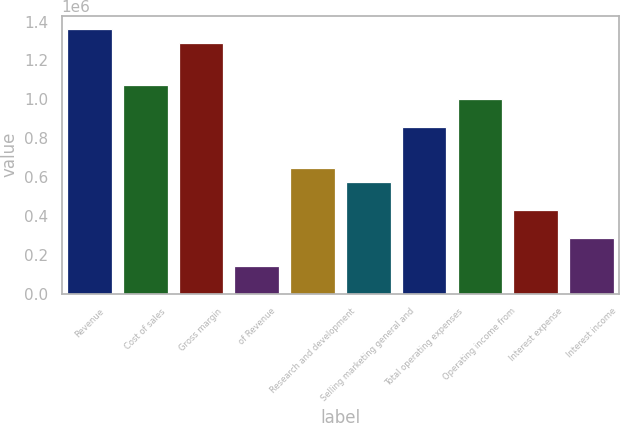Convert chart to OTSL. <chart><loc_0><loc_0><loc_500><loc_500><bar_chart><fcel>Revenue<fcel>Cost of sales<fcel>Gross margin<fcel>of Revenue<fcel>Research and development<fcel>Selling marketing general and<fcel>Total operating expenses<fcel>Operating income from<fcel>Interest expense<fcel>Interest income<nl><fcel>1.36065e+06<fcel>1.0742e+06<fcel>1.28904e+06<fcel>143227<fcel>644521<fcel>572907<fcel>859361<fcel>1.00259e+06<fcel>429680<fcel>286454<nl></chart> 